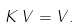Convert formula to latex. <formula><loc_0><loc_0><loc_500><loc_500>K \, V = V .</formula> 